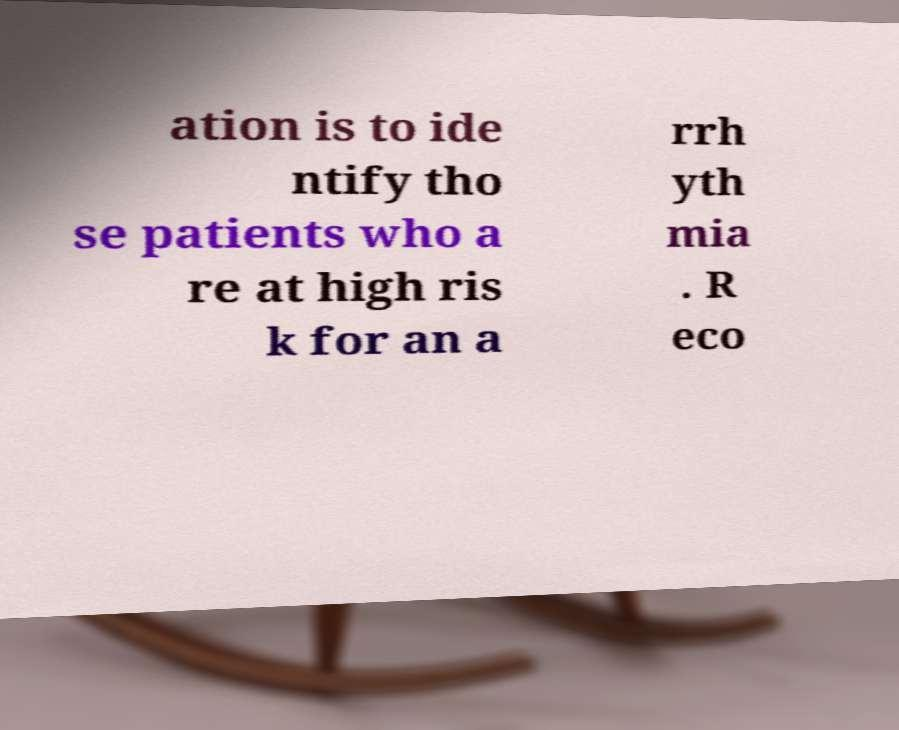Could you extract and type out the text from this image? ation is to ide ntify tho se patients who a re at high ris k for an a rrh yth mia . R eco 